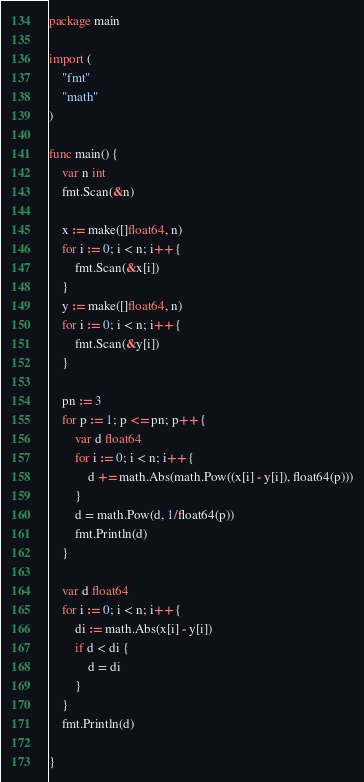Convert code to text. <code><loc_0><loc_0><loc_500><loc_500><_Go_>package main

import (
	"fmt"
	"math"
)

func main() {
	var n int
	fmt.Scan(&n)

	x := make([]float64, n)
	for i := 0; i < n; i++ {
		fmt.Scan(&x[i])
	}
	y := make([]float64, n)
	for i := 0; i < n; i++ {
		fmt.Scan(&y[i])
	}

	pn := 3
	for p := 1; p <= pn; p++ {
		var d float64
		for i := 0; i < n; i++ {
			d += math.Abs(math.Pow((x[i] - y[i]), float64(p)))
		}
		d = math.Pow(d, 1/float64(p))
		fmt.Println(d)
	}

	var d float64
	for i := 0; i < n; i++ {
		di := math.Abs(x[i] - y[i])
		if d < di {
			d = di
		}
	}
	fmt.Println(d)

}


</code> 